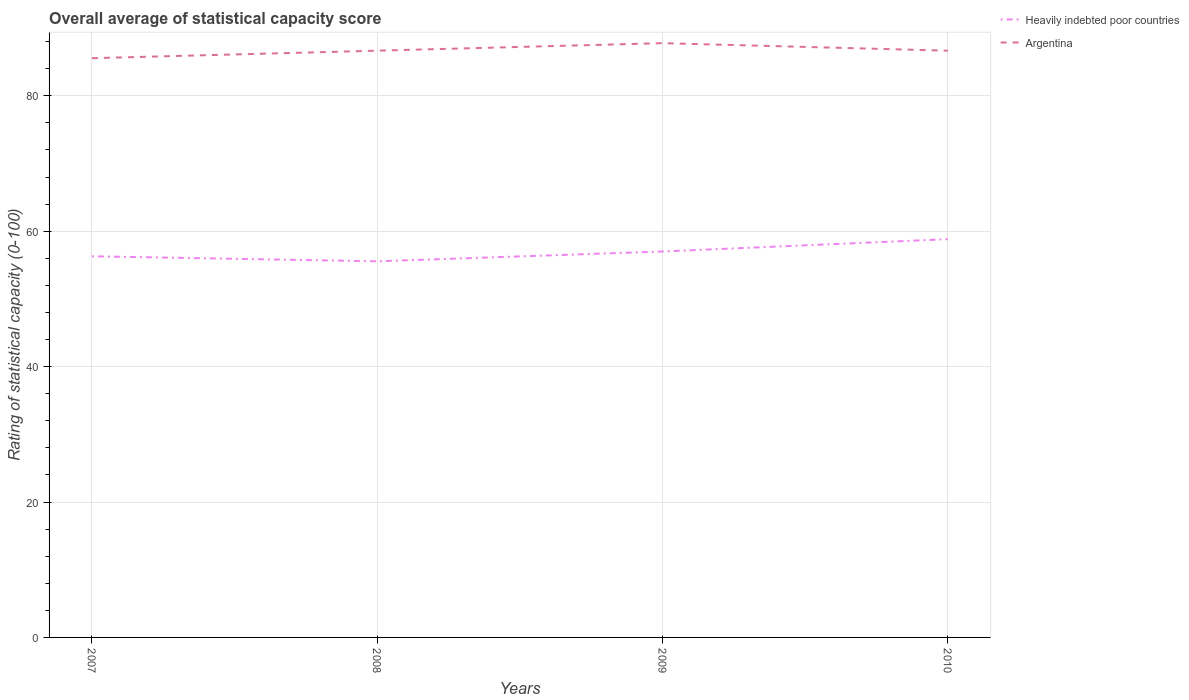How many different coloured lines are there?
Make the answer very short. 2. Is the number of lines equal to the number of legend labels?
Your response must be concise. Yes. Across all years, what is the maximum rating of statistical capacity in Argentina?
Your response must be concise. 85.56. In which year was the rating of statistical capacity in Argentina maximum?
Ensure brevity in your answer.  2007. What is the total rating of statistical capacity in Argentina in the graph?
Your answer should be very brief. -1.11. What is the difference between the highest and the second highest rating of statistical capacity in Argentina?
Provide a short and direct response. 2.22. Is the rating of statistical capacity in Argentina strictly greater than the rating of statistical capacity in Heavily indebted poor countries over the years?
Keep it short and to the point. No. Are the values on the major ticks of Y-axis written in scientific E-notation?
Your answer should be very brief. No. Does the graph contain any zero values?
Make the answer very short. No. Does the graph contain grids?
Your response must be concise. Yes. How many legend labels are there?
Keep it short and to the point. 2. How are the legend labels stacked?
Your response must be concise. Vertical. What is the title of the graph?
Your response must be concise. Overall average of statistical capacity score. Does "Brunei Darussalam" appear as one of the legend labels in the graph?
Keep it short and to the point. No. What is the label or title of the X-axis?
Give a very brief answer. Years. What is the label or title of the Y-axis?
Offer a terse response. Rating of statistical capacity (0-100). What is the Rating of statistical capacity (0-100) of Heavily indebted poor countries in 2007?
Provide a succinct answer. 56.3. What is the Rating of statistical capacity (0-100) of Argentina in 2007?
Offer a terse response. 85.56. What is the Rating of statistical capacity (0-100) of Heavily indebted poor countries in 2008?
Give a very brief answer. 55.56. What is the Rating of statistical capacity (0-100) of Argentina in 2008?
Keep it short and to the point. 86.67. What is the Rating of statistical capacity (0-100) in Heavily indebted poor countries in 2009?
Your response must be concise. 57.01. What is the Rating of statistical capacity (0-100) of Argentina in 2009?
Your answer should be very brief. 87.78. What is the Rating of statistical capacity (0-100) in Heavily indebted poor countries in 2010?
Keep it short and to the point. 58.83. What is the Rating of statistical capacity (0-100) in Argentina in 2010?
Your answer should be compact. 86.67. Across all years, what is the maximum Rating of statistical capacity (0-100) in Heavily indebted poor countries?
Keep it short and to the point. 58.83. Across all years, what is the maximum Rating of statistical capacity (0-100) of Argentina?
Provide a succinct answer. 87.78. Across all years, what is the minimum Rating of statistical capacity (0-100) in Heavily indebted poor countries?
Give a very brief answer. 55.56. Across all years, what is the minimum Rating of statistical capacity (0-100) of Argentina?
Your answer should be compact. 85.56. What is the total Rating of statistical capacity (0-100) of Heavily indebted poor countries in the graph?
Give a very brief answer. 227.69. What is the total Rating of statistical capacity (0-100) of Argentina in the graph?
Offer a very short reply. 346.67. What is the difference between the Rating of statistical capacity (0-100) of Heavily indebted poor countries in 2007 and that in 2008?
Ensure brevity in your answer.  0.74. What is the difference between the Rating of statistical capacity (0-100) of Argentina in 2007 and that in 2008?
Your answer should be compact. -1.11. What is the difference between the Rating of statistical capacity (0-100) of Heavily indebted poor countries in 2007 and that in 2009?
Make the answer very short. -0.71. What is the difference between the Rating of statistical capacity (0-100) in Argentina in 2007 and that in 2009?
Give a very brief answer. -2.22. What is the difference between the Rating of statistical capacity (0-100) in Heavily indebted poor countries in 2007 and that in 2010?
Your answer should be compact. -2.53. What is the difference between the Rating of statistical capacity (0-100) of Argentina in 2007 and that in 2010?
Offer a terse response. -1.11. What is the difference between the Rating of statistical capacity (0-100) of Heavily indebted poor countries in 2008 and that in 2009?
Offer a terse response. -1.45. What is the difference between the Rating of statistical capacity (0-100) of Argentina in 2008 and that in 2009?
Ensure brevity in your answer.  -1.11. What is the difference between the Rating of statistical capacity (0-100) in Heavily indebted poor countries in 2008 and that in 2010?
Your answer should be very brief. -3.27. What is the difference between the Rating of statistical capacity (0-100) of Heavily indebted poor countries in 2009 and that in 2010?
Your response must be concise. -1.82. What is the difference between the Rating of statistical capacity (0-100) in Heavily indebted poor countries in 2007 and the Rating of statistical capacity (0-100) in Argentina in 2008?
Provide a succinct answer. -30.37. What is the difference between the Rating of statistical capacity (0-100) in Heavily indebted poor countries in 2007 and the Rating of statistical capacity (0-100) in Argentina in 2009?
Ensure brevity in your answer.  -31.48. What is the difference between the Rating of statistical capacity (0-100) in Heavily indebted poor countries in 2007 and the Rating of statistical capacity (0-100) in Argentina in 2010?
Make the answer very short. -30.37. What is the difference between the Rating of statistical capacity (0-100) of Heavily indebted poor countries in 2008 and the Rating of statistical capacity (0-100) of Argentina in 2009?
Your response must be concise. -32.22. What is the difference between the Rating of statistical capacity (0-100) of Heavily indebted poor countries in 2008 and the Rating of statistical capacity (0-100) of Argentina in 2010?
Offer a terse response. -31.11. What is the difference between the Rating of statistical capacity (0-100) of Heavily indebted poor countries in 2009 and the Rating of statistical capacity (0-100) of Argentina in 2010?
Provide a short and direct response. -29.66. What is the average Rating of statistical capacity (0-100) in Heavily indebted poor countries per year?
Give a very brief answer. 56.92. What is the average Rating of statistical capacity (0-100) of Argentina per year?
Keep it short and to the point. 86.67. In the year 2007, what is the difference between the Rating of statistical capacity (0-100) in Heavily indebted poor countries and Rating of statistical capacity (0-100) in Argentina?
Offer a terse response. -29.26. In the year 2008, what is the difference between the Rating of statistical capacity (0-100) in Heavily indebted poor countries and Rating of statistical capacity (0-100) in Argentina?
Keep it short and to the point. -31.11. In the year 2009, what is the difference between the Rating of statistical capacity (0-100) in Heavily indebted poor countries and Rating of statistical capacity (0-100) in Argentina?
Make the answer very short. -30.77. In the year 2010, what is the difference between the Rating of statistical capacity (0-100) in Heavily indebted poor countries and Rating of statistical capacity (0-100) in Argentina?
Give a very brief answer. -27.84. What is the ratio of the Rating of statistical capacity (0-100) of Heavily indebted poor countries in 2007 to that in 2008?
Your answer should be compact. 1.01. What is the ratio of the Rating of statistical capacity (0-100) in Argentina in 2007 to that in 2008?
Make the answer very short. 0.99. What is the ratio of the Rating of statistical capacity (0-100) in Heavily indebted poor countries in 2007 to that in 2009?
Keep it short and to the point. 0.99. What is the ratio of the Rating of statistical capacity (0-100) of Argentina in 2007 to that in 2009?
Offer a very short reply. 0.97. What is the ratio of the Rating of statistical capacity (0-100) of Argentina in 2007 to that in 2010?
Your response must be concise. 0.99. What is the ratio of the Rating of statistical capacity (0-100) of Heavily indebted poor countries in 2008 to that in 2009?
Make the answer very short. 0.97. What is the ratio of the Rating of statistical capacity (0-100) in Argentina in 2008 to that in 2009?
Keep it short and to the point. 0.99. What is the ratio of the Rating of statistical capacity (0-100) of Heavily indebted poor countries in 2008 to that in 2010?
Keep it short and to the point. 0.94. What is the ratio of the Rating of statistical capacity (0-100) of Argentina in 2008 to that in 2010?
Your response must be concise. 1. What is the ratio of the Rating of statistical capacity (0-100) of Heavily indebted poor countries in 2009 to that in 2010?
Give a very brief answer. 0.97. What is the ratio of the Rating of statistical capacity (0-100) in Argentina in 2009 to that in 2010?
Your answer should be very brief. 1.01. What is the difference between the highest and the second highest Rating of statistical capacity (0-100) of Heavily indebted poor countries?
Offer a terse response. 1.82. What is the difference between the highest and the lowest Rating of statistical capacity (0-100) of Heavily indebted poor countries?
Your answer should be compact. 3.27. What is the difference between the highest and the lowest Rating of statistical capacity (0-100) in Argentina?
Provide a short and direct response. 2.22. 